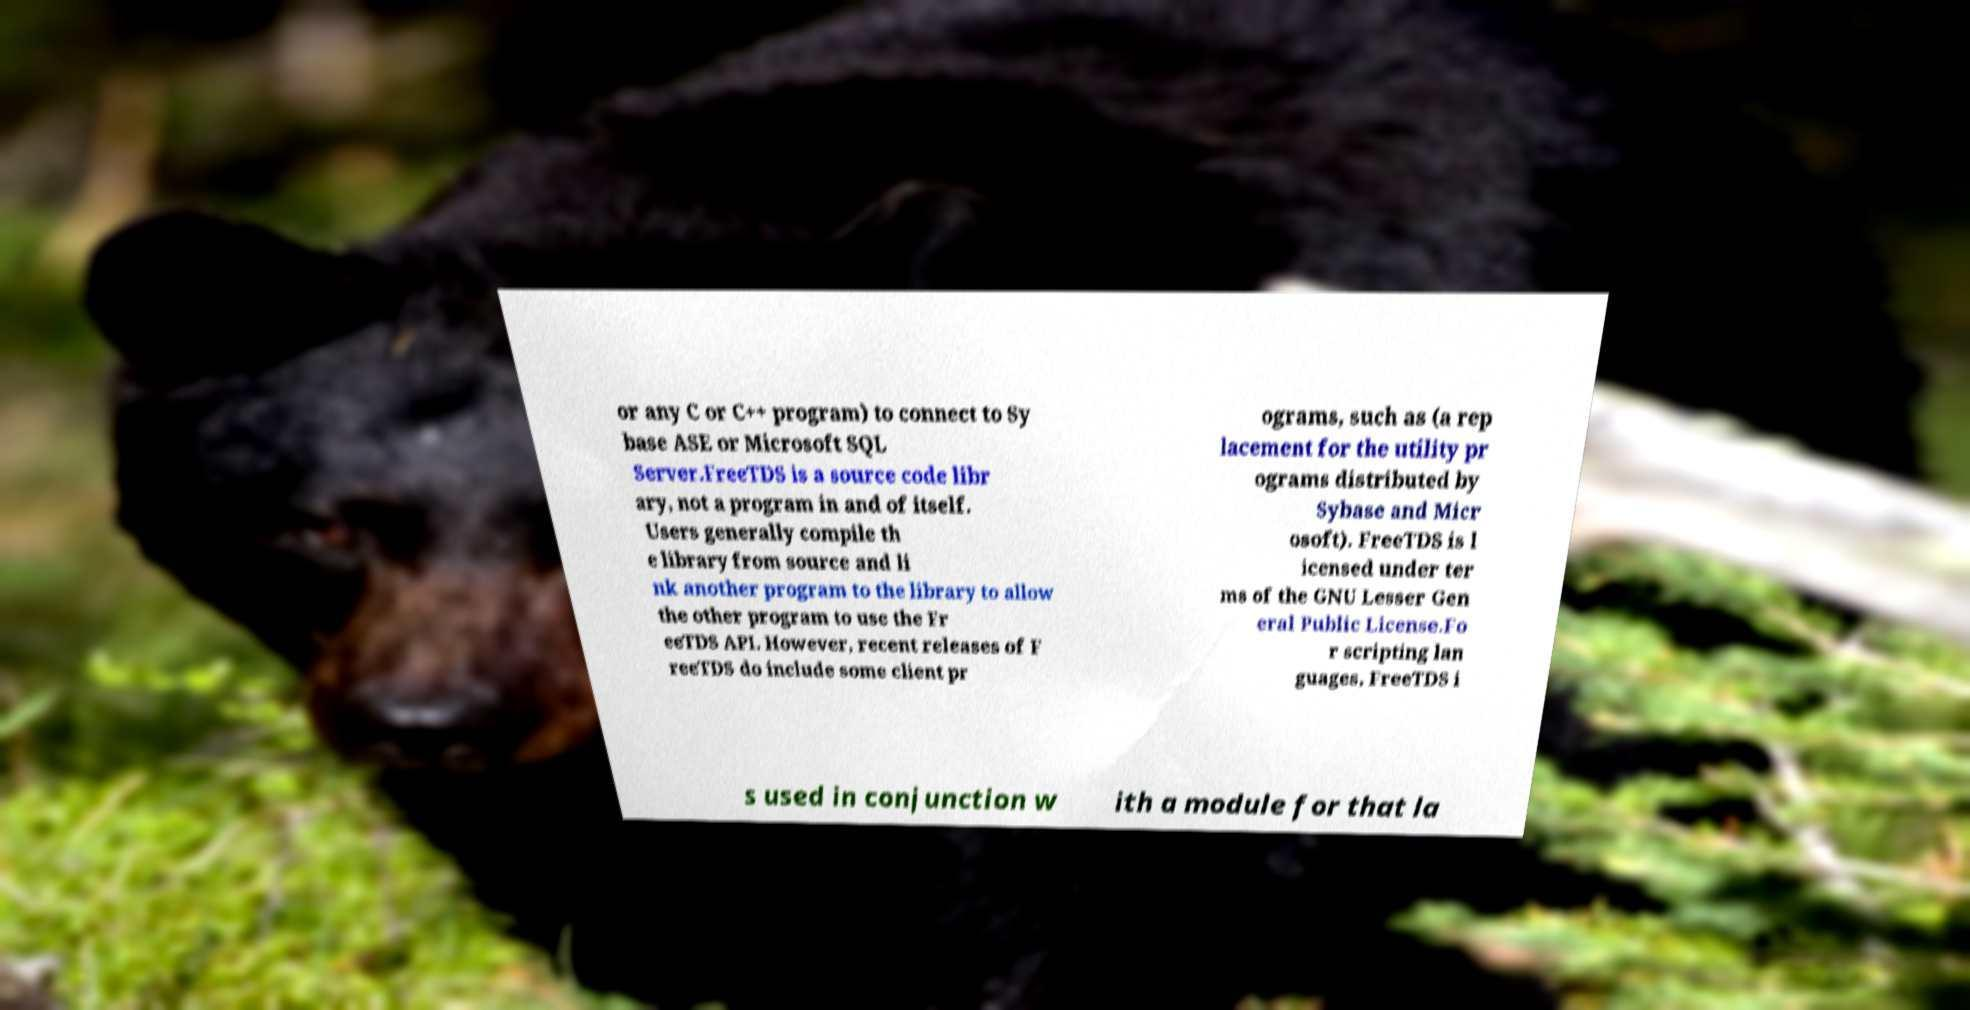Could you assist in decoding the text presented in this image and type it out clearly? or any C or C++ program) to connect to Sy base ASE or Microsoft SQL Server.FreeTDS is a source code libr ary, not a program in and of itself. Users generally compile th e library from source and li nk another program to the library to allow the other program to use the Fr eeTDS API. However, recent releases of F reeTDS do include some client pr ograms, such as (a rep lacement for the utility pr ograms distributed by Sybase and Micr osoft). FreeTDS is l icensed under ter ms of the GNU Lesser Gen eral Public License.Fo r scripting lan guages, FreeTDS i s used in conjunction w ith a module for that la 